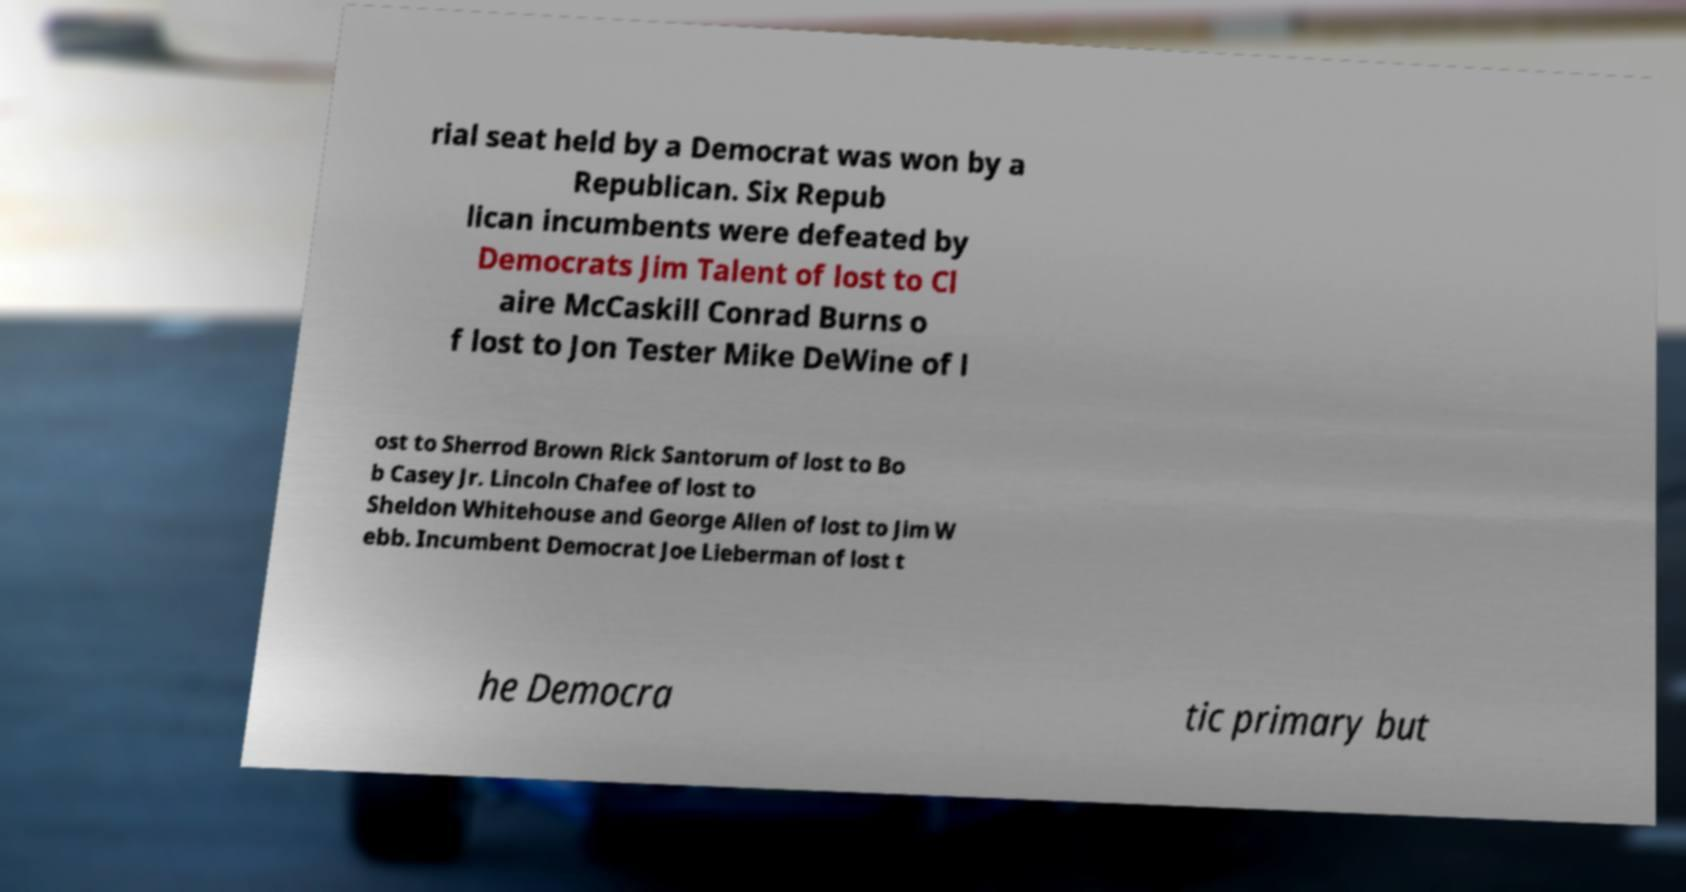What messages or text are displayed in this image? I need them in a readable, typed format. rial seat held by a Democrat was won by a Republican. Six Repub lican incumbents were defeated by Democrats Jim Talent of lost to Cl aire McCaskill Conrad Burns o f lost to Jon Tester Mike DeWine of l ost to Sherrod Brown Rick Santorum of lost to Bo b Casey Jr. Lincoln Chafee of lost to Sheldon Whitehouse and George Allen of lost to Jim W ebb. Incumbent Democrat Joe Lieberman of lost t he Democra tic primary but 